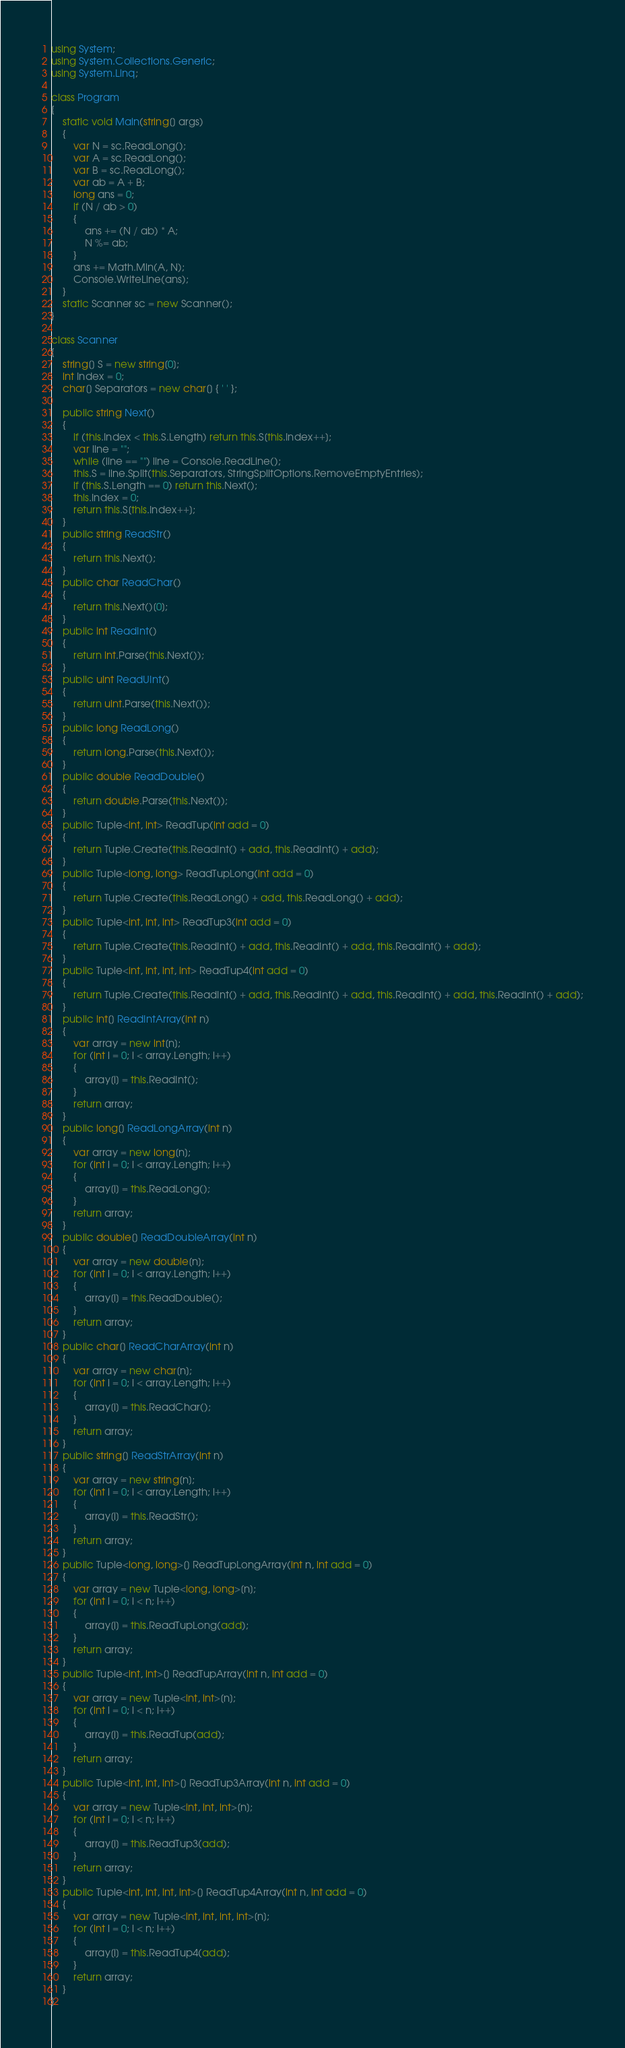<code> <loc_0><loc_0><loc_500><loc_500><_C#_>using System;
using System.Collections.Generic;
using System.Linq;

class Program
{
    static void Main(string[] args)
    {
        var N = sc.ReadLong();
        var A = sc.ReadLong();
        var B = sc.ReadLong();
        var ab = A + B;
        long ans = 0;
        if (N / ab > 0)
        {
            ans += (N / ab) * A;
            N %= ab;
        }
        ans += Math.Min(A, N);
        Console.WriteLine(ans);
    }
    static Scanner sc = new Scanner();
}

class Scanner
{
    string[] S = new string[0];
    int Index = 0;
    char[] Separators = new char[] { ' ' };

    public string Next()
    {
        if (this.Index < this.S.Length) return this.S[this.Index++];
        var line = "";
        while (line == "") line = Console.ReadLine();
        this.S = line.Split(this.Separators, StringSplitOptions.RemoveEmptyEntries);
        if (this.S.Length == 0) return this.Next();
        this.Index = 0;
        return this.S[this.Index++];
    }
    public string ReadStr()
    {
        return this.Next();
    }
    public char ReadChar()
    {
        return this.Next()[0];
    }
    public int ReadInt()
    {
        return int.Parse(this.Next());
    }
    public uint ReadUInt()
    {
        return uint.Parse(this.Next());
    }
    public long ReadLong()
    {
        return long.Parse(this.Next());
    }
    public double ReadDouble()
    {
        return double.Parse(this.Next());
    }
    public Tuple<int, int> ReadTup(int add = 0)
    {
        return Tuple.Create(this.ReadInt() + add, this.ReadInt() + add);
    }
    public Tuple<long, long> ReadTupLong(int add = 0)
    {
        return Tuple.Create(this.ReadLong() + add, this.ReadLong() + add);
    }
    public Tuple<int, int, int> ReadTup3(int add = 0)
    {
        return Tuple.Create(this.ReadInt() + add, this.ReadInt() + add, this.ReadInt() + add);
    }
    public Tuple<int, int, int, int> ReadTup4(int add = 0)
    {
        return Tuple.Create(this.ReadInt() + add, this.ReadInt() + add, this.ReadInt() + add, this.ReadInt() + add);
    }
    public int[] ReadIntArray(int n)
    {
        var array = new int[n];
        for (int i = 0; i < array.Length; i++)
        {
            array[i] = this.ReadInt();
        }
        return array;
    }
    public long[] ReadLongArray(int n)
    {
        var array = new long[n];
        for (int i = 0; i < array.Length; i++)
        {
            array[i] = this.ReadLong();
        }
        return array;
    }
    public double[] ReadDoubleArray(int n)
    {
        var array = new double[n];
        for (int i = 0; i < array.Length; i++)
        {
            array[i] = this.ReadDouble();
        }
        return array;
    }
    public char[] ReadCharArray(int n)
    {
        var array = new char[n];
        for (int i = 0; i < array.Length; i++)
        {
            array[i] = this.ReadChar();
        }
        return array;
    }
    public string[] ReadStrArray(int n)
    {
        var array = new string[n];
        for (int i = 0; i < array.Length; i++)
        {
            array[i] = this.ReadStr();
        }
        return array;
    }
    public Tuple<long, long>[] ReadTupLongArray(int n, int add = 0)
    {
        var array = new Tuple<long, long>[n];
        for (int i = 0; i < n; i++)
        {
            array[i] = this.ReadTupLong(add);
        }
        return array;
    }
    public Tuple<int, int>[] ReadTupArray(int n, int add = 0)
    {
        var array = new Tuple<int, int>[n];
        for (int i = 0; i < n; i++)
        {
            array[i] = this.ReadTup(add);
        }
        return array;
    }
    public Tuple<int, int, int>[] ReadTup3Array(int n, int add = 0)
    {
        var array = new Tuple<int, int, int>[n];
        for (int i = 0; i < n; i++)
        {
            array[i] = this.ReadTup3(add);
        }
        return array;
    }
    public Tuple<int, int, int, int>[] ReadTup4Array(int n, int add = 0)
    {
        var array = new Tuple<int, int, int, int>[n];
        for (int i = 0; i < n; i++)
        {
            array[i] = this.ReadTup4(add);
        }
        return array;
    }
}
</code> 